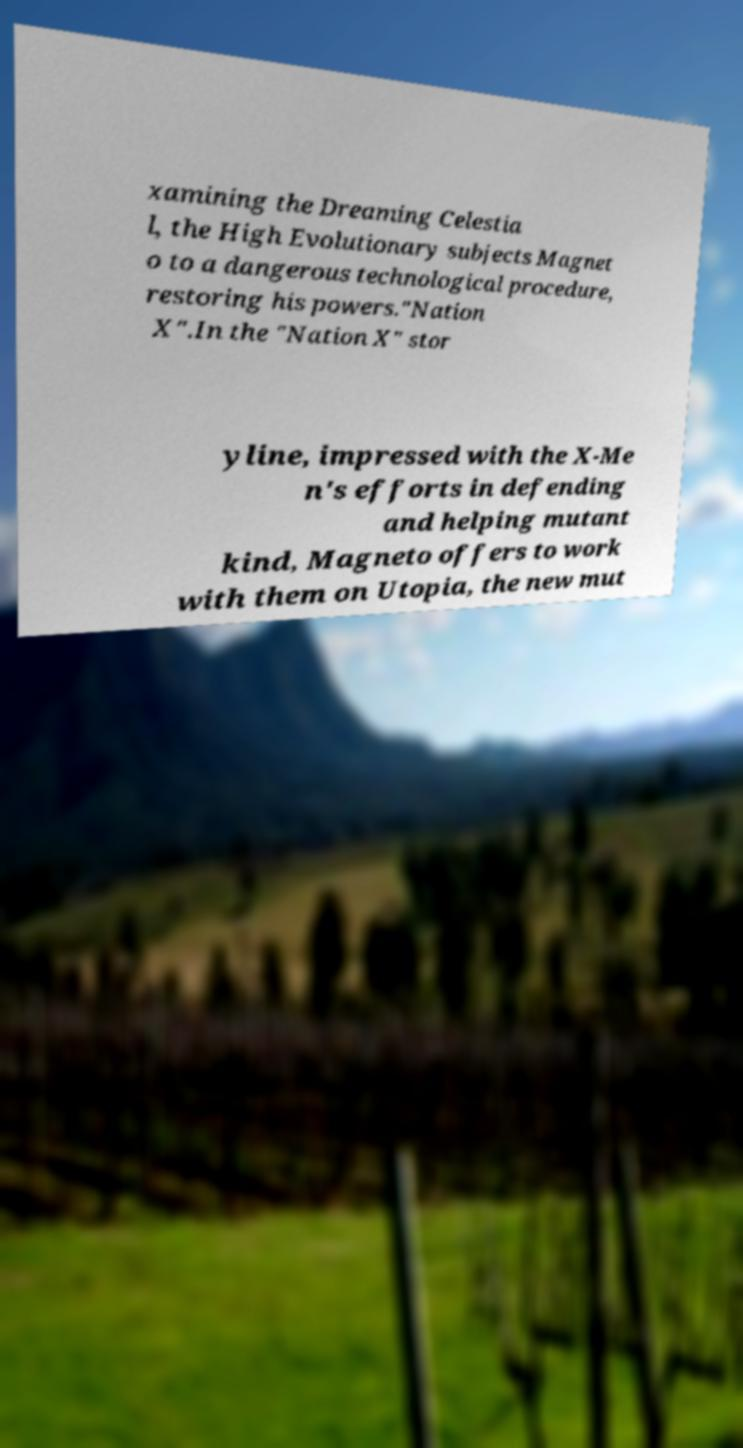Can you read and provide the text displayed in the image?This photo seems to have some interesting text. Can you extract and type it out for me? xamining the Dreaming Celestia l, the High Evolutionary subjects Magnet o to a dangerous technological procedure, restoring his powers."Nation X".In the "Nation X" stor yline, impressed with the X-Me n's efforts in defending and helping mutant kind, Magneto offers to work with them on Utopia, the new mut 